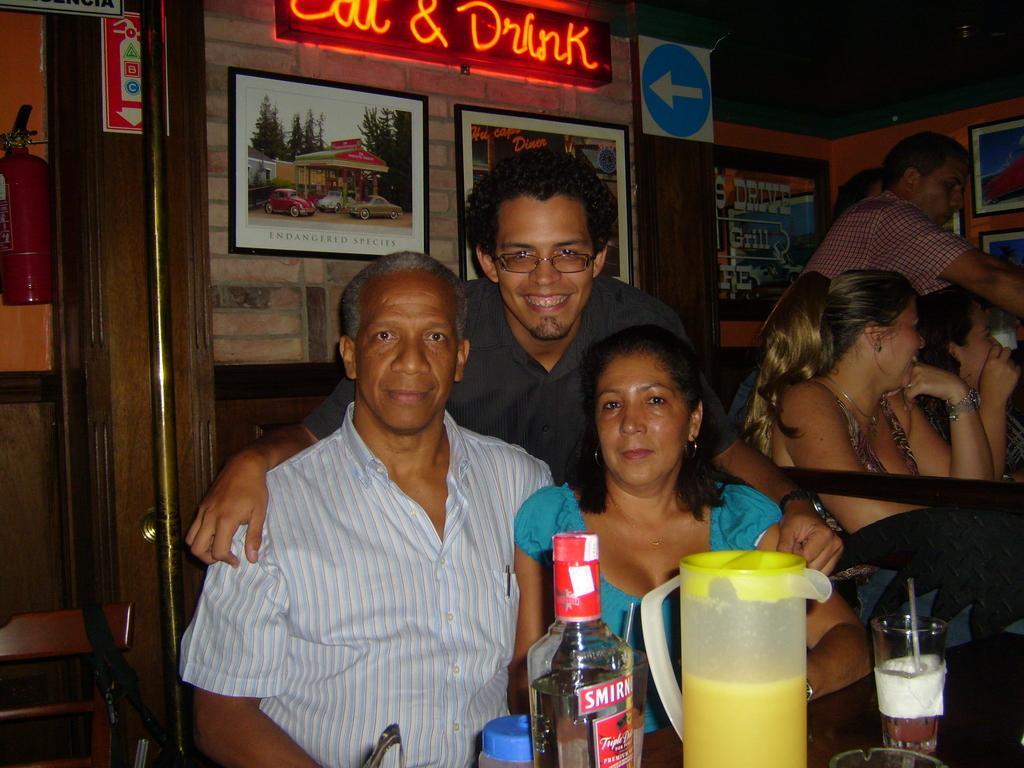In one or two sentences, can you explain what this image depicts? In this image in front people are sitting on the chairs. In front of them there is a table and on top of the table there is a jar, glass, bottle and a few other objects. On the backside there is a wall with the photo frames attached to it. Beside the wall there is a door and we can see stool, fire extinguisher in front of the door. 